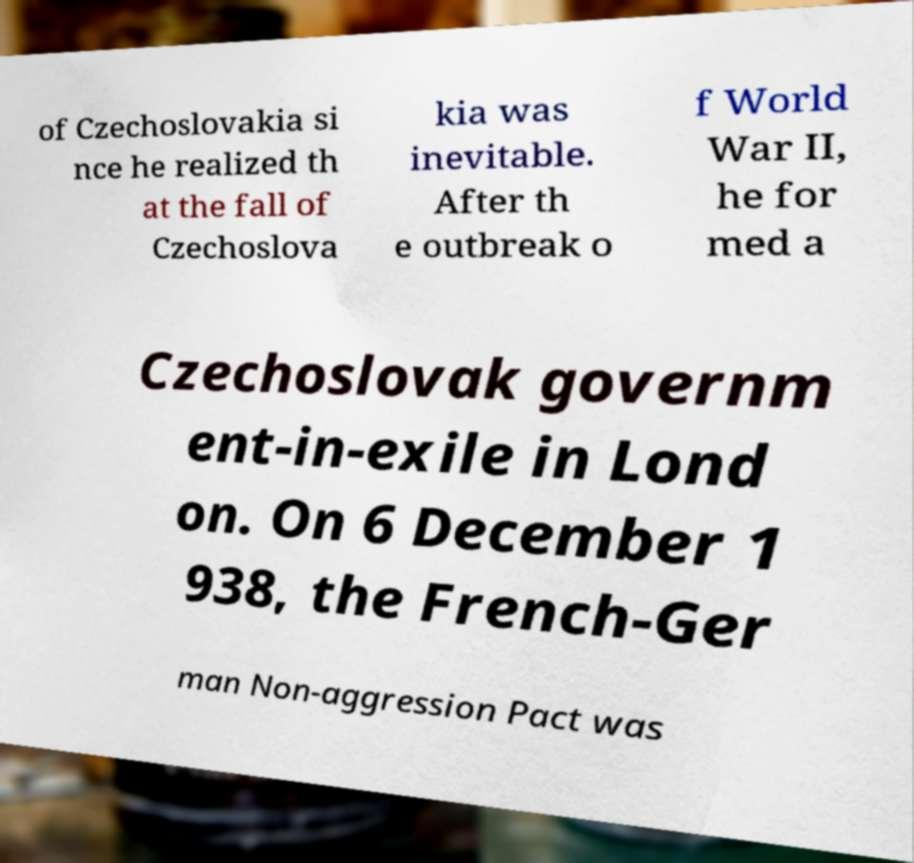Please read and relay the text visible in this image. What does it say? of Czechoslovakia si nce he realized th at the fall of Czechoslova kia was inevitable. After th e outbreak o f World War II, he for med a Czechoslovak governm ent-in-exile in Lond on. On 6 December 1 938, the French-Ger man Non-aggression Pact was 